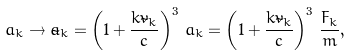Convert formula to latex. <formula><loc_0><loc_0><loc_500><loc_500>a _ { k } \to \tilde { a } _ { k } = \left ( { 1 + \frac { k \tilde { v } _ { k } } { c } } \right ) ^ { 3 } \, a _ { k } = \left ( { 1 + \frac { k \tilde { v } _ { k } } { c } } \right ) ^ { 3 } \, \frac { F _ { k } } { m } ,</formula> 